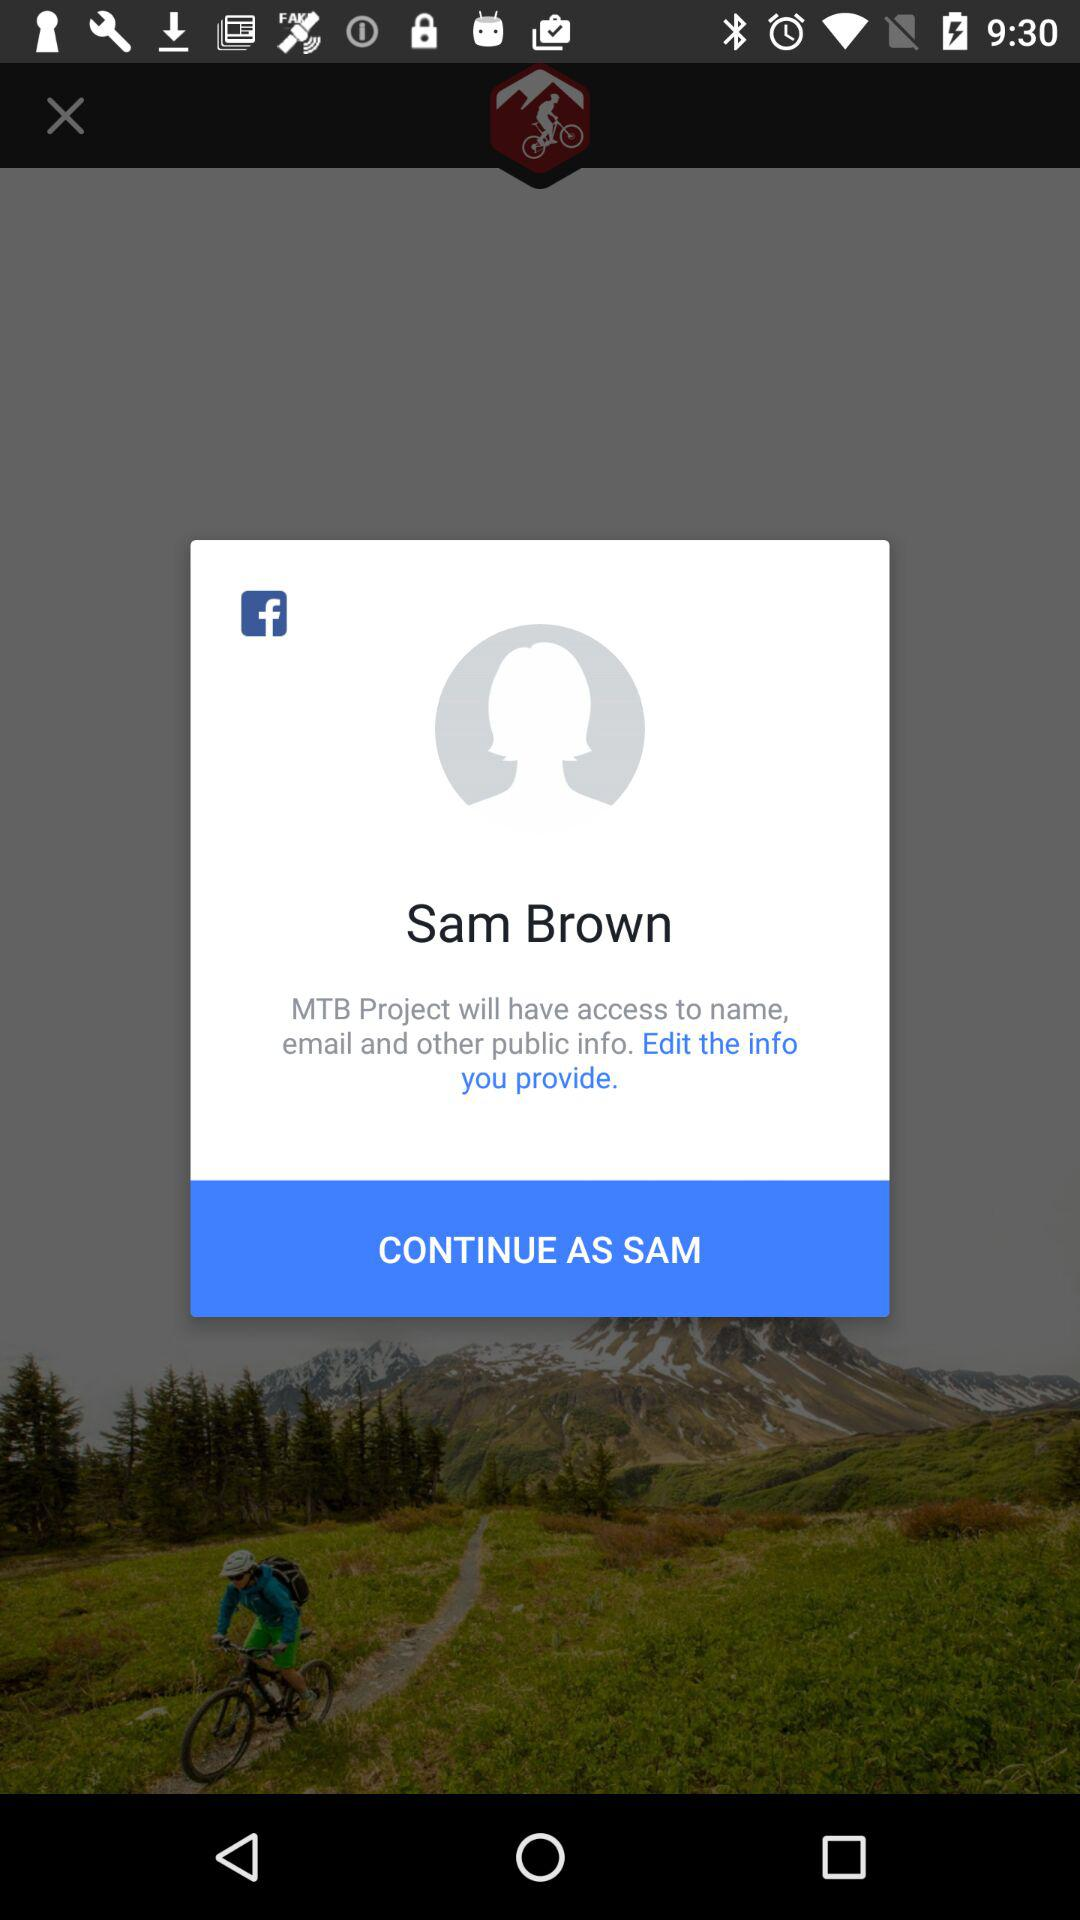What is the user name? The user name is Sam Brown. 